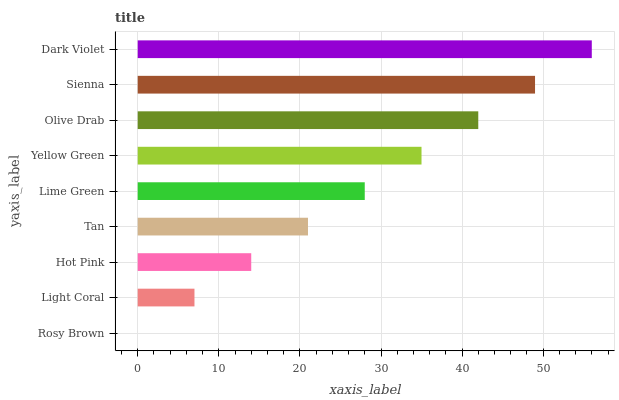Is Rosy Brown the minimum?
Answer yes or no. Yes. Is Dark Violet the maximum?
Answer yes or no. Yes. Is Light Coral the minimum?
Answer yes or no. No. Is Light Coral the maximum?
Answer yes or no. No. Is Light Coral greater than Rosy Brown?
Answer yes or no. Yes. Is Rosy Brown less than Light Coral?
Answer yes or no. Yes. Is Rosy Brown greater than Light Coral?
Answer yes or no. No. Is Light Coral less than Rosy Brown?
Answer yes or no. No. Is Lime Green the high median?
Answer yes or no. Yes. Is Lime Green the low median?
Answer yes or no. Yes. Is Rosy Brown the high median?
Answer yes or no. No. Is Yellow Green the low median?
Answer yes or no. No. 